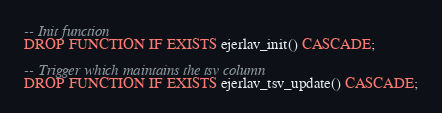Convert code to text. <code><loc_0><loc_0><loc_500><loc_500><_SQL_>-- Init function
DROP FUNCTION IF EXISTS ejerlav_init() CASCADE;

-- Trigger which maintains the tsv column
DROP FUNCTION IF EXISTS ejerlav_tsv_update() CASCADE;
</code> 